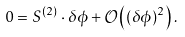Convert formula to latex. <formula><loc_0><loc_0><loc_500><loc_500>0 = S ^ { ( 2 ) } \cdot \delta \phi + { \mathcal { O } } \left ( ( \delta \phi ) ^ { 2 } \right ) .</formula> 